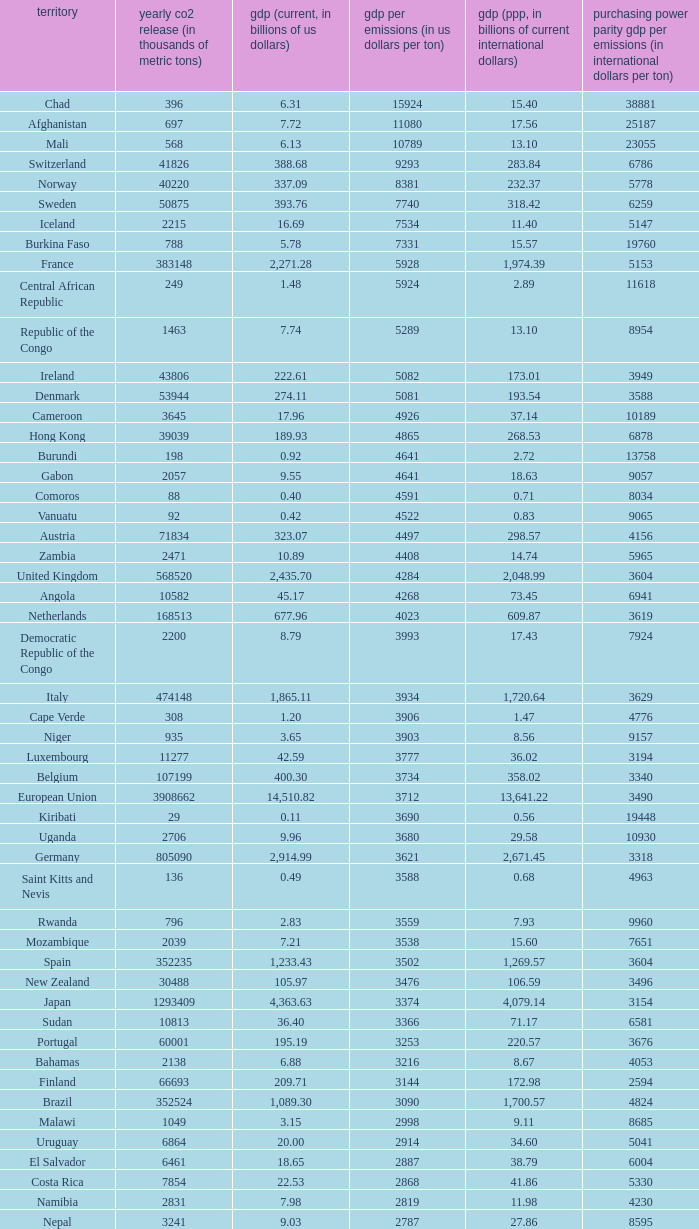When the annual co2 emissions (in thousands of metric tons) is 1811, what is the country? Haiti. 